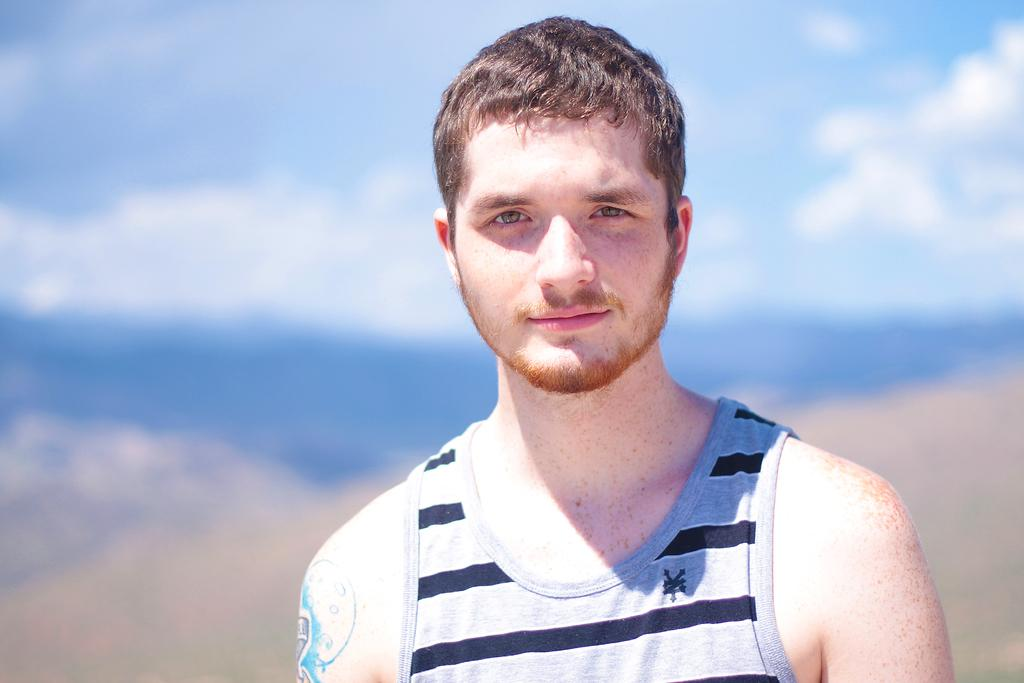Who is present in the image? There is a man standing in the image. What can be seen in the background of the image? The sky is blue and cloudy in the image. How many crates are being carried by the man in the image? There are no crates present in the image; only a man standing is visible. What type of gun is being held by the man's brother in the image? There is no gun or brother present in the image; only a man standing is visible. 